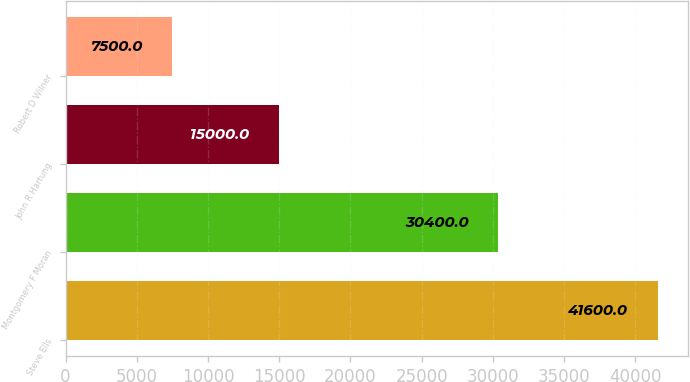<chart> <loc_0><loc_0><loc_500><loc_500><bar_chart><fcel>Steve Ells<fcel>Montgomery F Moran<fcel>John R Hartung<fcel>Robert D Wilner<nl><fcel>41600<fcel>30400<fcel>15000<fcel>7500<nl></chart> 